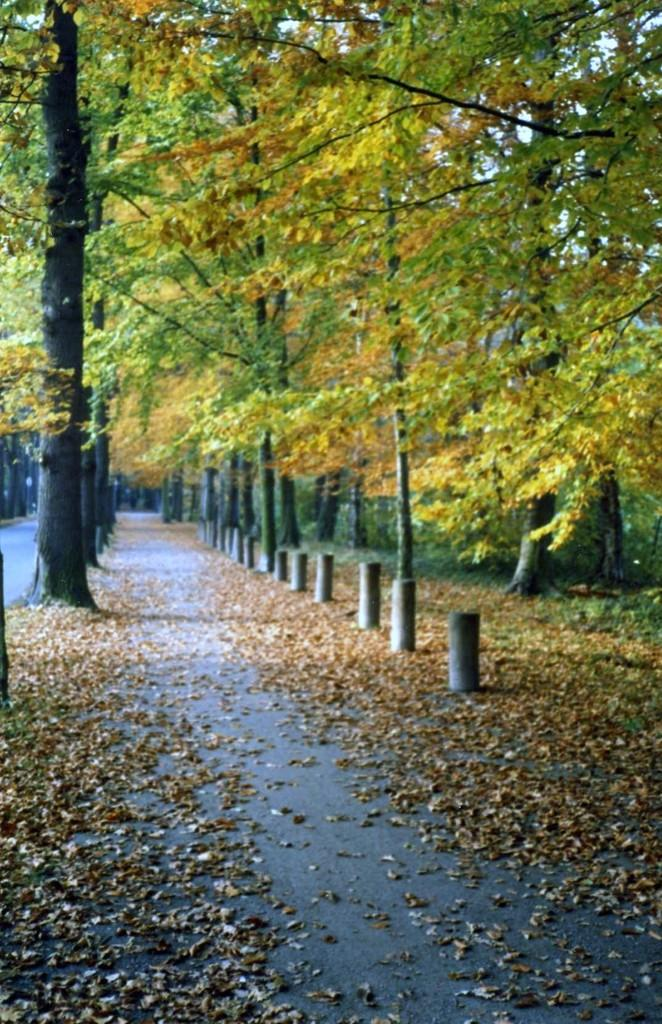What type of vegetation is present in the image? There are many trees and grass in the image. What structures can be seen in the image? There are poles and a walkway in the image. What additional details can be observed in the image? There are leaves in the image. What type of lace can be seen on the trees in the image? There is no lace present on the trees in the image; it is a natural scene with trees, grass, and leaves. Is there a car visible in the image? No, there is no car present in the image. 